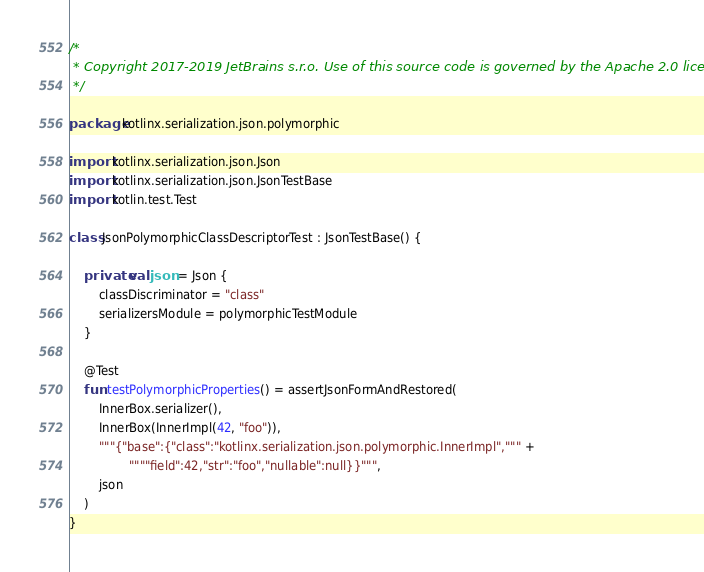Convert code to text. <code><loc_0><loc_0><loc_500><loc_500><_Kotlin_>/*
 * Copyright 2017-2019 JetBrains s.r.o. Use of this source code is governed by the Apache 2.0 license.
 */

package kotlinx.serialization.json.polymorphic

import kotlinx.serialization.json.Json
import kotlinx.serialization.json.JsonTestBase
import kotlin.test.Test

class JsonPolymorphicClassDescriptorTest : JsonTestBase() {

    private val json = Json {
        classDiscriminator = "class"
        serializersModule = polymorphicTestModule
    }

    @Test
    fun testPolymorphicProperties() = assertJsonFormAndRestored(
        InnerBox.serializer(),
        InnerBox(InnerImpl(42, "foo")),
        """{"base":{"class":"kotlinx.serialization.json.polymorphic.InnerImpl",""" +
                """"field":42,"str":"foo","nullable":null}}""",
        json
    )
}
</code> 